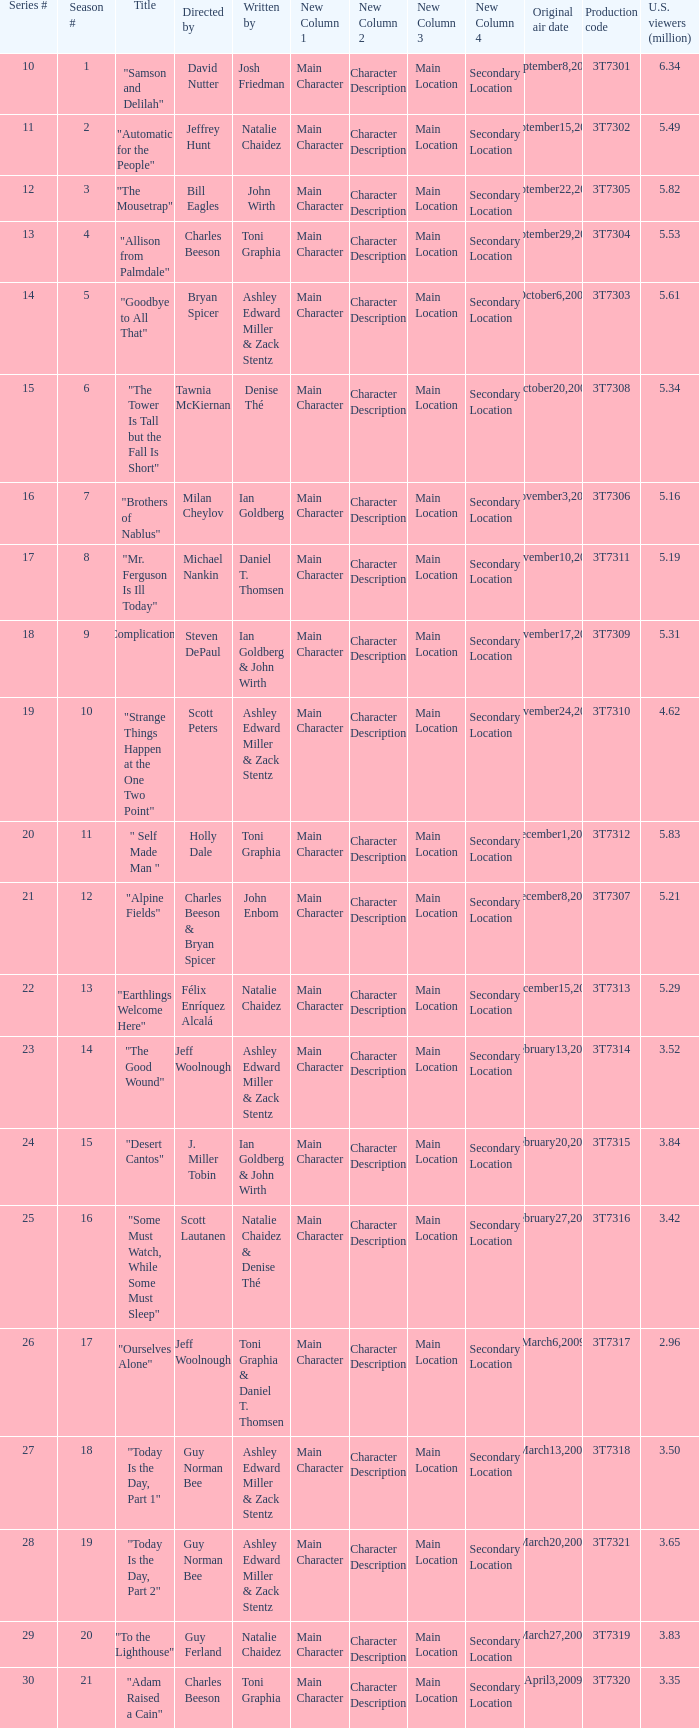Which episode number drew in 3.35 million viewers in the United States? 1.0. Help me parse the entirety of this table. {'header': ['Series #', 'Season #', 'Title', 'Directed by', 'Written by', 'New Column 1', 'New Column 2', 'New Column 3', 'New Column 4', 'Original air date', 'Production code', 'U.S. viewers (million)'], 'rows': [['10', '1', '"Samson and Delilah"', 'David Nutter', 'Josh Friedman', 'Main Character', 'Character Description', 'Main Location', 'Secondary Location', 'September8,2008', '3T7301', '6.34'], ['11', '2', '"Automatic for the People"', 'Jeffrey Hunt', 'Natalie Chaidez', 'Main Character', 'Character Description', 'Main Location', 'Secondary Location', 'September15,2008', '3T7302', '5.49'], ['12', '3', '"The Mousetrap"', 'Bill Eagles', 'John Wirth', 'Main Character', 'Character Description', 'Main Location', 'Secondary Location', 'September22,2008', '3T7305', '5.82'], ['13', '4', '"Allison from Palmdale"', 'Charles Beeson', 'Toni Graphia', 'Main Character', 'Character Description', 'Main Location', 'Secondary Location', 'September29,2008', '3T7304', '5.53'], ['14', '5', '"Goodbye to All That"', 'Bryan Spicer', 'Ashley Edward Miller & Zack Stentz', 'Main Character', 'Character Description', 'Main Location', 'Secondary Location', 'October6,2008', '3T7303', '5.61'], ['15', '6', '"The Tower Is Tall but the Fall Is Short"', 'Tawnia McKiernan', 'Denise Thé', 'Main Character', 'Character Description', 'Main Location', 'Secondary Location', 'October20,2008', '3T7308', '5.34'], ['16', '7', '"Brothers of Nablus"', 'Milan Cheylov', 'Ian Goldberg', 'Main Character', 'Character Description', 'Main Location', 'Secondary Location', 'November3,2008', '3T7306', '5.16'], ['17', '8', '"Mr. Ferguson Is Ill Today"', 'Michael Nankin', 'Daniel T. Thomsen', 'Main Character', 'Character Description', 'Main Location', 'Secondary Location', 'November10,2008', '3T7311', '5.19'], ['18', '9', '"Complications"', 'Steven DePaul', 'Ian Goldberg & John Wirth', 'Main Character', 'Character Description', 'Main Location', 'Secondary Location', 'November17,2008', '3T7309', '5.31'], ['19', '10', '"Strange Things Happen at the One Two Point"', 'Scott Peters', 'Ashley Edward Miller & Zack Stentz', 'Main Character', 'Character Description', 'Main Location', 'Secondary Location', 'November24,2008', '3T7310', '4.62'], ['20', '11', '" Self Made Man "', 'Holly Dale', 'Toni Graphia', 'Main Character', 'Character Description', 'Main Location', 'Secondary Location', 'December1,2008', '3T7312', '5.83'], ['21', '12', '"Alpine Fields"', 'Charles Beeson & Bryan Spicer', 'John Enbom', 'Main Character', 'Character Description', 'Main Location', 'Secondary Location', 'December8,2008', '3T7307', '5.21'], ['22', '13', '"Earthlings Welcome Here"', 'Félix Enríquez Alcalá', 'Natalie Chaidez', 'Main Character', 'Character Description', 'Main Location', 'Secondary Location', 'December15,2008', '3T7313', '5.29'], ['23', '14', '"The Good Wound"', 'Jeff Woolnough', 'Ashley Edward Miller & Zack Stentz', 'Main Character', 'Character Description', 'Main Location', 'Secondary Location', 'February13,2009', '3T7314', '3.52'], ['24', '15', '"Desert Cantos"', 'J. Miller Tobin', 'Ian Goldberg & John Wirth', 'Main Character', 'Character Description', 'Main Location', 'Secondary Location', 'February20,2009', '3T7315', '3.84'], ['25', '16', '"Some Must Watch, While Some Must Sleep"', 'Scott Lautanen', 'Natalie Chaidez & Denise Thé', 'Main Character', 'Character Description', 'Main Location', 'Secondary Location', 'February27,2009', '3T7316', '3.42'], ['26', '17', '"Ourselves Alone"', 'Jeff Woolnough', 'Toni Graphia & Daniel T. Thomsen', 'Main Character', 'Character Description', 'Main Location', 'Secondary Location', 'March6,2009', '3T7317', '2.96'], ['27', '18', '"Today Is the Day, Part 1"', 'Guy Norman Bee', 'Ashley Edward Miller & Zack Stentz', 'Main Character', 'Character Description', 'Main Location', 'Secondary Location', 'March13,2009', '3T7318', '3.50'], ['28', '19', '"Today Is the Day, Part 2"', 'Guy Norman Bee', 'Ashley Edward Miller & Zack Stentz', 'Main Character', 'Character Description', 'Main Location', 'Secondary Location', 'March20,2009', '3T7321', '3.65'], ['29', '20', '"To the Lighthouse"', 'Guy Ferland', 'Natalie Chaidez', 'Main Character', 'Character Description', 'Main Location', 'Secondary Location', 'March27,2009', '3T7319', '3.83'], ['30', '21', '"Adam Raised a Cain"', 'Charles Beeson', 'Toni Graphia', 'Main Character', 'Character Description', 'Main Location', 'Secondary Location', 'April3,2009', '3T7320', '3.35']]} 